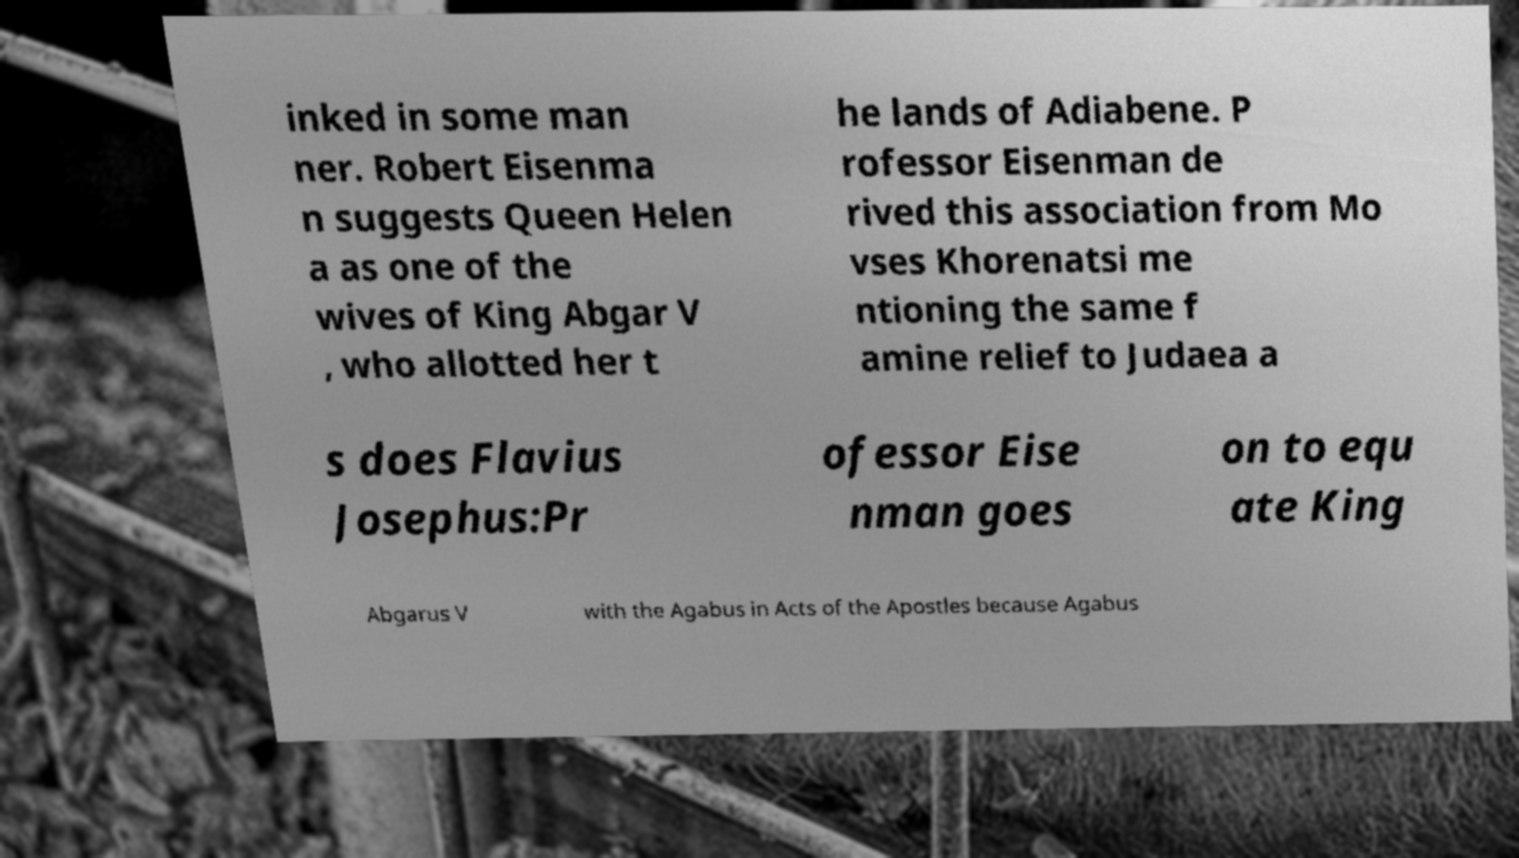For documentation purposes, I need the text within this image transcribed. Could you provide that? inked in some man ner. Robert Eisenma n suggests Queen Helen a as one of the wives of King Abgar V , who allotted her t he lands of Adiabene. P rofessor Eisenman de rived this association from Mo vses Khorenatsi me ntioning the same f amine relief to Judaea a s does Flavius Josephus:Pr ofessor Eise nman goes on to equ ate King Abgarus V with the Agabus in Acts of the Apostles because Agabus 